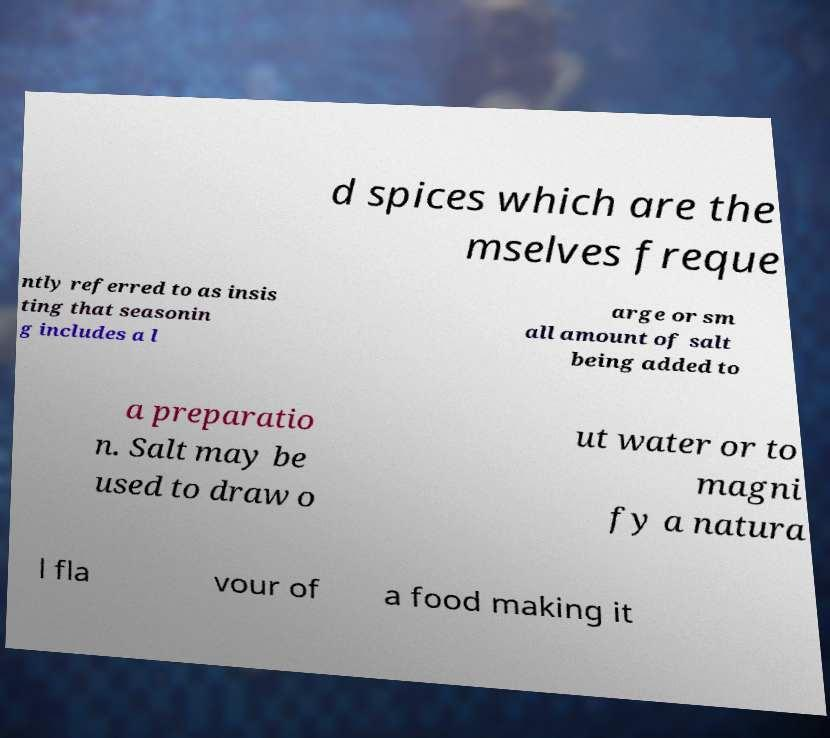Can you read and provide the text displayed in the image?This photo seems to have some interesting text. Can you extract and type it out for me? d spices which are the mselves freque ntly referred to as insis ting that seasonin g includes a l arge or sm all amount of salt being added to a preparatio n. Salt may be used to draw o ut water or to magni fy a natura l fla vour of a food making it 